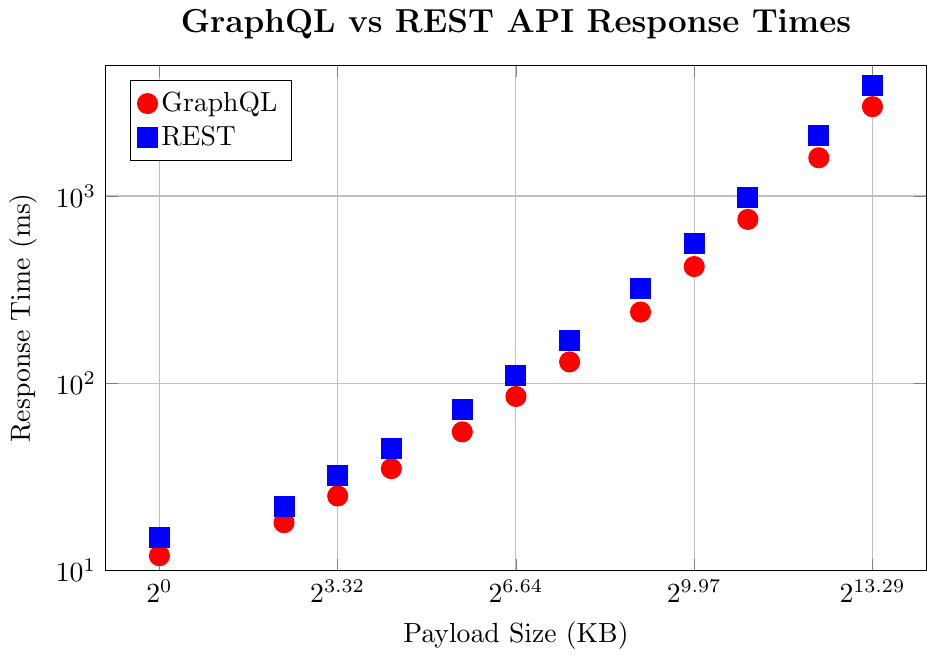Which API has a faster response time for a 1000 KB payload? Look at the response times for a 1000 KB payload on the graph. The red dot (GraphQL) is at approximately 420 ms, and the blue square (REST) is at approximately 560 ms.
Answer: GraphQL At 5000 KB, how much slower is REST compared to GraphQL? Identify the response times for both APIs at 5000 KB. For GraphQL, it's 1600 ms, and for REST, it's 2100 ms. Subtract the GraphQL time from the REST time: 2100 - 1600 = 500 ms.
Answer: 500 ms Does GraphQL or REST scale better with larger payload sizes? Observe how the response times increase for both GraphQL and REST as the payload size increases. GraphQL's curve increases more slowly than REST's curve, indicating that GraphQL scales better.
Answer: GraphQL For which payload sizes does REST's response time exceed twice that of GraphQL? Check the response times for each payload size. For 100, 2000, 5000, and 10000 KB, REST times are 110, 980, 2100, and 3900 ms, while GraphQL times are 85, 750, 1600, and 3000 ms. Only for 10000 KB does REST exceed twice (3000*2 < 3900).
Answer: 10000 KB What's the difference in response time between GraphQL and REST for a 50 KB payload? Find the response times for 50 KB. GraphQL is 55 ms, and REST is 72 ms. Subtract them: 72 - 55 = 17 ms.
Answer: 17 ms At which payload size does the gap between GraphQL and REST response times first exceed 100 ms? Compare gaps: At 200 KB: 170 - 130 = 40 ms. At 500 KB: 320 - 240 = 80 ms. At 1000 KB: 560 - 420 = 140 ms. Thus, at 1000 KB, the gap first exceeds 100 ms.
Answer: 1000 KB At a payload size of 200 KB, which API is faster and by how much? Lookup 200 KB response times: GraphQL is 130 ms, and REST is 170 ms. Subtract GraphQL from REST: 170 - 130 = 40 ms.
Answer: GraphQL by 40 ms How does the response time of GraphQL at 100 KB compare to the response time of REST at 50 KB? Find 100 KB for GraphQL (85 ms) and 50 KB for REST (72 ms). GraphQL at 100 KB is 85 - 72 = 13 ms slower than REST at 50 KB.
Answer: 13 ms slower Which payload sizes have the smallest and largest differences in response times between GraphQL and REST? Check each payload size's differences: Smallest at 1 KB: 15 - 12 = 3 ms. Largest at 10000 KB: 3900 - 3000 = 900 ms.
Answer: 1 KB and 10000 KB 